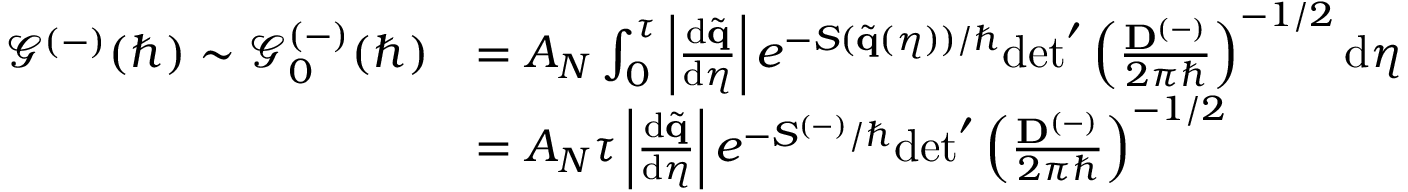<formula> <loc_0><loc_0><loc_500><loc_500>\begin{array} { r l } { \mathcal { G } ^ { ( - ) } ( \hbar { ) } \sim \mathcal { G } _ { 0 } ^ { ( - ) } ( \hbar { ) } } & { = A _ { N } \int _ { 0 } ^ { \tau } \left | \frac { d \tilde { q } } { d \eta } \right | e ^ { - S ( \tilde { q } ( \eta ) ) / } d e t ^ { \prime } \left ( \frac { D ^ { ( - ) } } { 2 \pi } \right ) ^ { - 1 / 2 } d \eta } \\ & { = A _ { N } \tau \left | \frac { d \tilde { q } } { d \eta } \right | e ^ { - S ^ { ( - ) } / } d e t ^ { \prime } \left ( \frac { D ^ { ( - ) } } { 2 \pi } \right ) ^ { - 1 / 2 } } \end{array}</formula> 